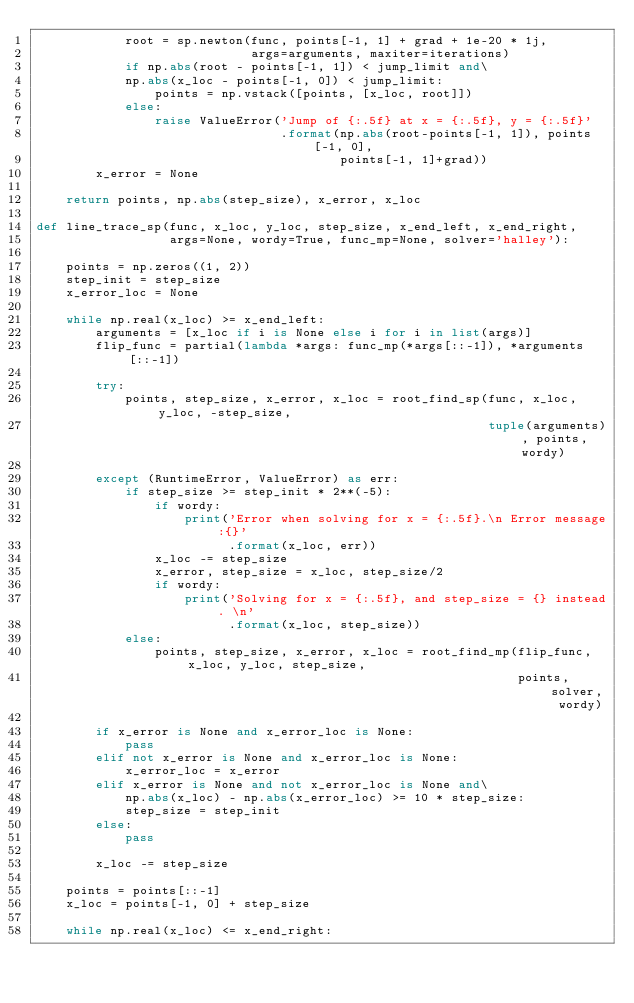Convert code to text. <code><loc_0><loc_0><loc_500><loc_500><_Python_>            root = sp.newton(func, points[-1, 1] + grad + 1e-20 * 1j,
                             args=arguments, maxiter=iterations)
            if np.abs(root - points[-1, 1]) < jump_limit and\
            np.abs(x_loc - points[-1, 0]) < jump_limit:
                points = np.vstack([points, [x_loc, root]])
            else:
                raise ValueError('Jump of {:.5f} at x = {:.5f}, y = {:.5f}'
                                 .format(np.abs(root-points[-1, 1]), points[-1, 0],
                                         points[-1, 1]+grad))
        x_error = None

    return points, np.abs(step_size), x_error, x_loc

def line_trace_sp(func, x_loc, y_loc, step_size, x_end_left, x_end_right,
                  args=None, wordy=True, func_mp=None, solver='halley'):

    points = np.zeros((1, 2))
    step_init = step_size
    x_error_loc = None

    while np.real(x_loc) >= x_end_left:
        arguments = [x_loc if i is None else i for i in list(args)]
        flip_func = partial(lambda *args: func_mp(*args[::-1]), *arguments[::-1])

        try:
            points, step_size, x_error, x_loc = root_find_sp(func, x_loc, y_loc, -step_size,
                                                             tuple(arguments), points, wordy)

        except (RuntimeError, ValueError) as err:
            if step_size >= step_init * 2**(-5):
                if wordy:
                    print('Error when solving for x = {:.5f}.\n Error message:{}'
                          .format(x_loc, err))
                x_loc -= step_size
                x_error, step_size = x_loc, step_size/2
                if wordy:
                    print('Solving for x = {:.5f}, and step_size = {} instead. \n'
                          .format(x_loc, step_size))
            else:
                points, step_size, x_error, x_loc = root_find_mp(flip_func, x_loc, y_loc, step_size,
                                                                 points, solver, wordy)

        if x_error is None and x_error_loc is None:
            pass
        elif not x_error is None and x_error_loc is None:
            x_error_loc = x_error
        elif x_error is None and not x_error_loc is None and\
            np.abs(x_loc) - np.abs(x_error_loc) >= 10 * step_size:
            step_size = step_init
        else:
            pass

        x_loc -= step_size

    points = points[::-1]
    x_loc = points[-1, 0] + step_size

    while np.real(x_loc) <= x_end_right:</code> 